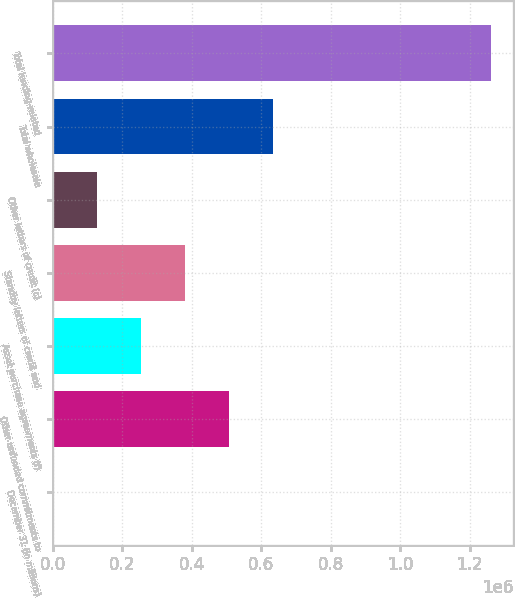<chart> <loc_0><loc_0><loc_500><loc_500><bar_chart><fcel>December 31 (in millions)<fcel>Other unfunded commitments to<fcel>Asset purchase agreements (f)<fcel>Standby letters of credit and<fcel>Other letters of credit (c)<fcel>Total wholesale<fcel>Total lending-related<nl><fcel>2007<fcel>506239<fcel>254123<fcel>380181<fcel>128065<fcel>632298<fcel>1.26259e+06<nl></chart> 